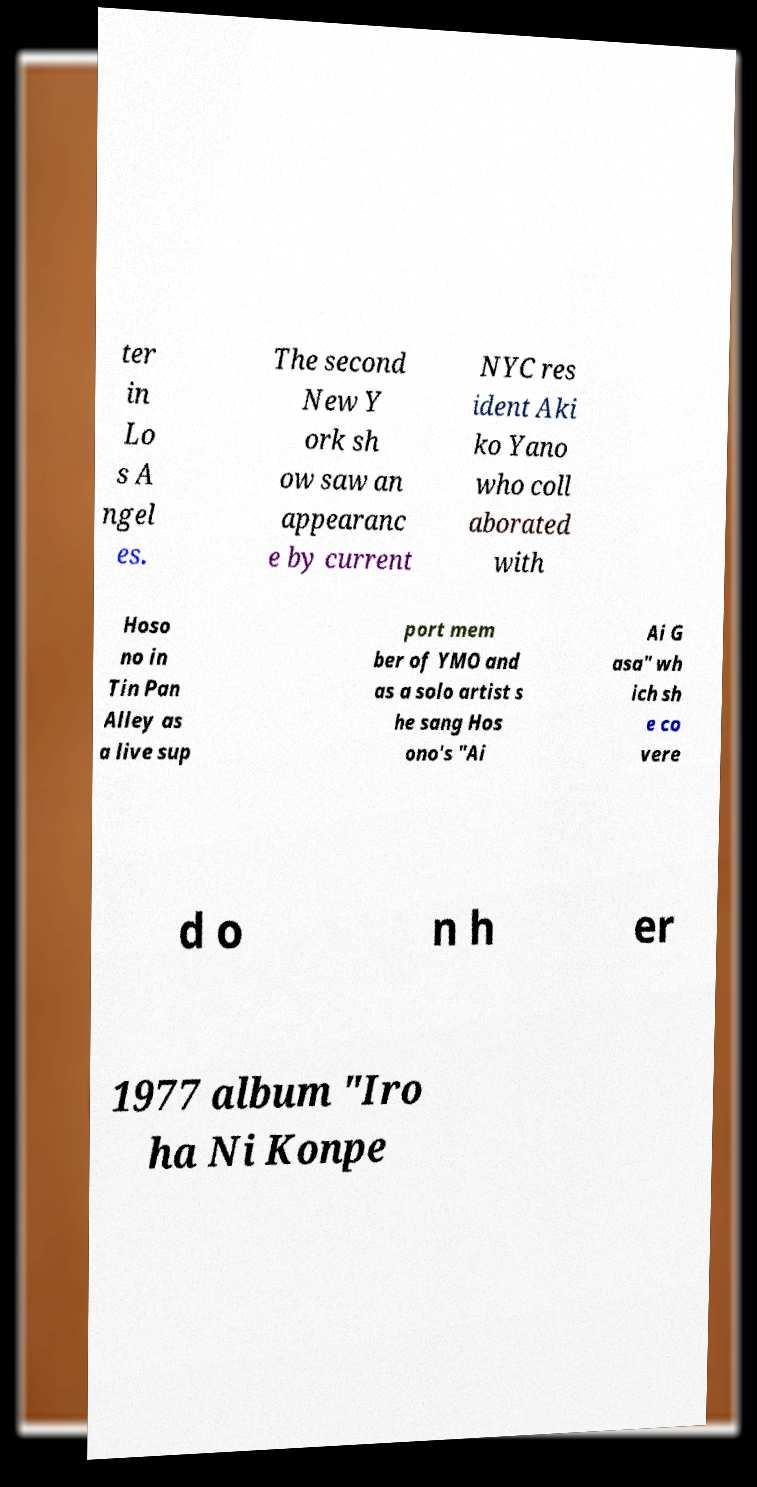I need the written content from this picture converted into text. Can you do that? ter in Lo s A ngel es. The second New Y ork sh ow saw an appearanc e by current NYC res ident Aki ko Yano who coll aborated with Hoso no in Tin Pan Alley as a live sup port mem ber of YMO and as a solo artist s he sang Hos ono's "Ai Ai G asa" wh ich sh e co vere d o n h er 1977 album "Iro ha Ni Konpe 